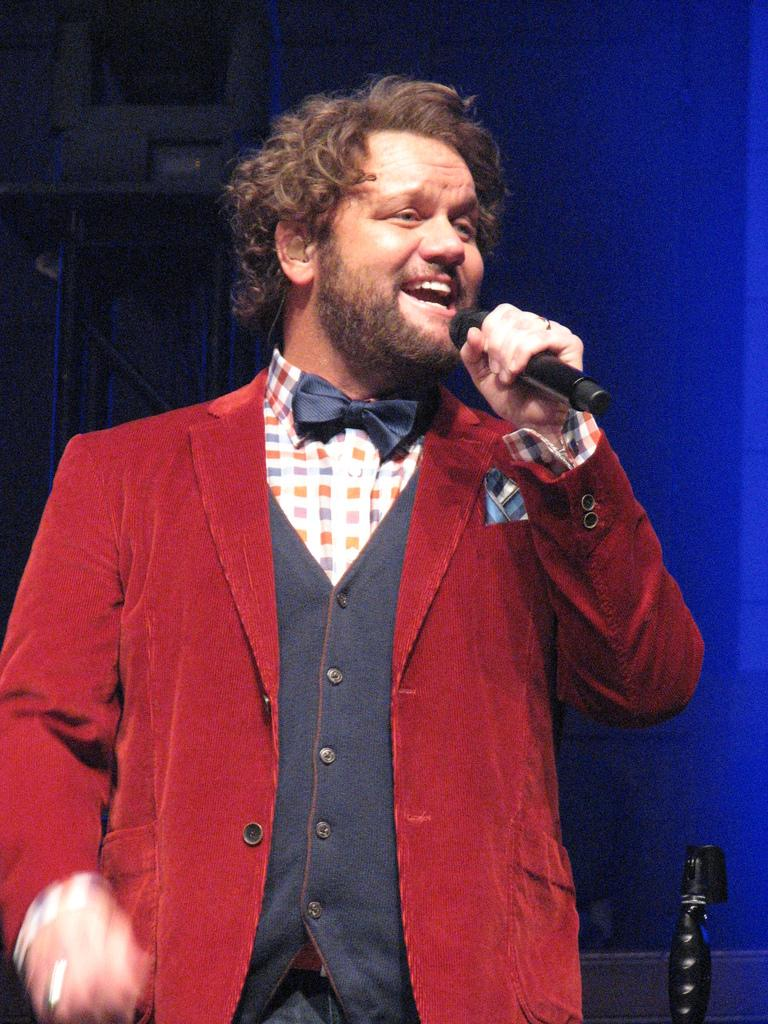What is the person in the image doing? The person is holding a mic and talking. What might the person be using the mic for? The person might be using the mic for public speaking or performing. What object is beside the person? There is an object beside the person, but its description is not provided in the facts. What can be seen behind the person? There is a wall visible in the image. What is the color of the background in the image? The background of the image is blue in color. How does the person's health improve in the image? There is no information about the person's health in the image, so it cannot be determined if their health improves or not. 